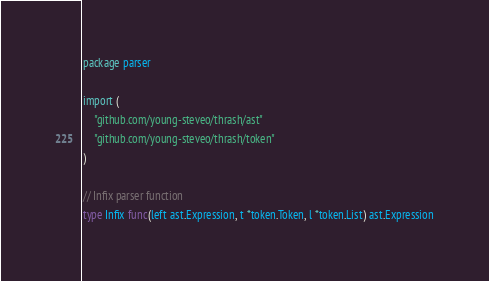<code> <loc_0><loc_0><loc_500><loc_500><_Go_>package parser

import (
	"github.com/young-steveo/thrash/ast"
	"github.com/young-steveo/thrash/token"
)

// Infix parser function
type Infix func(left ast.Expression, t *token.Token, l *token.List) ast.Expression
</code> 